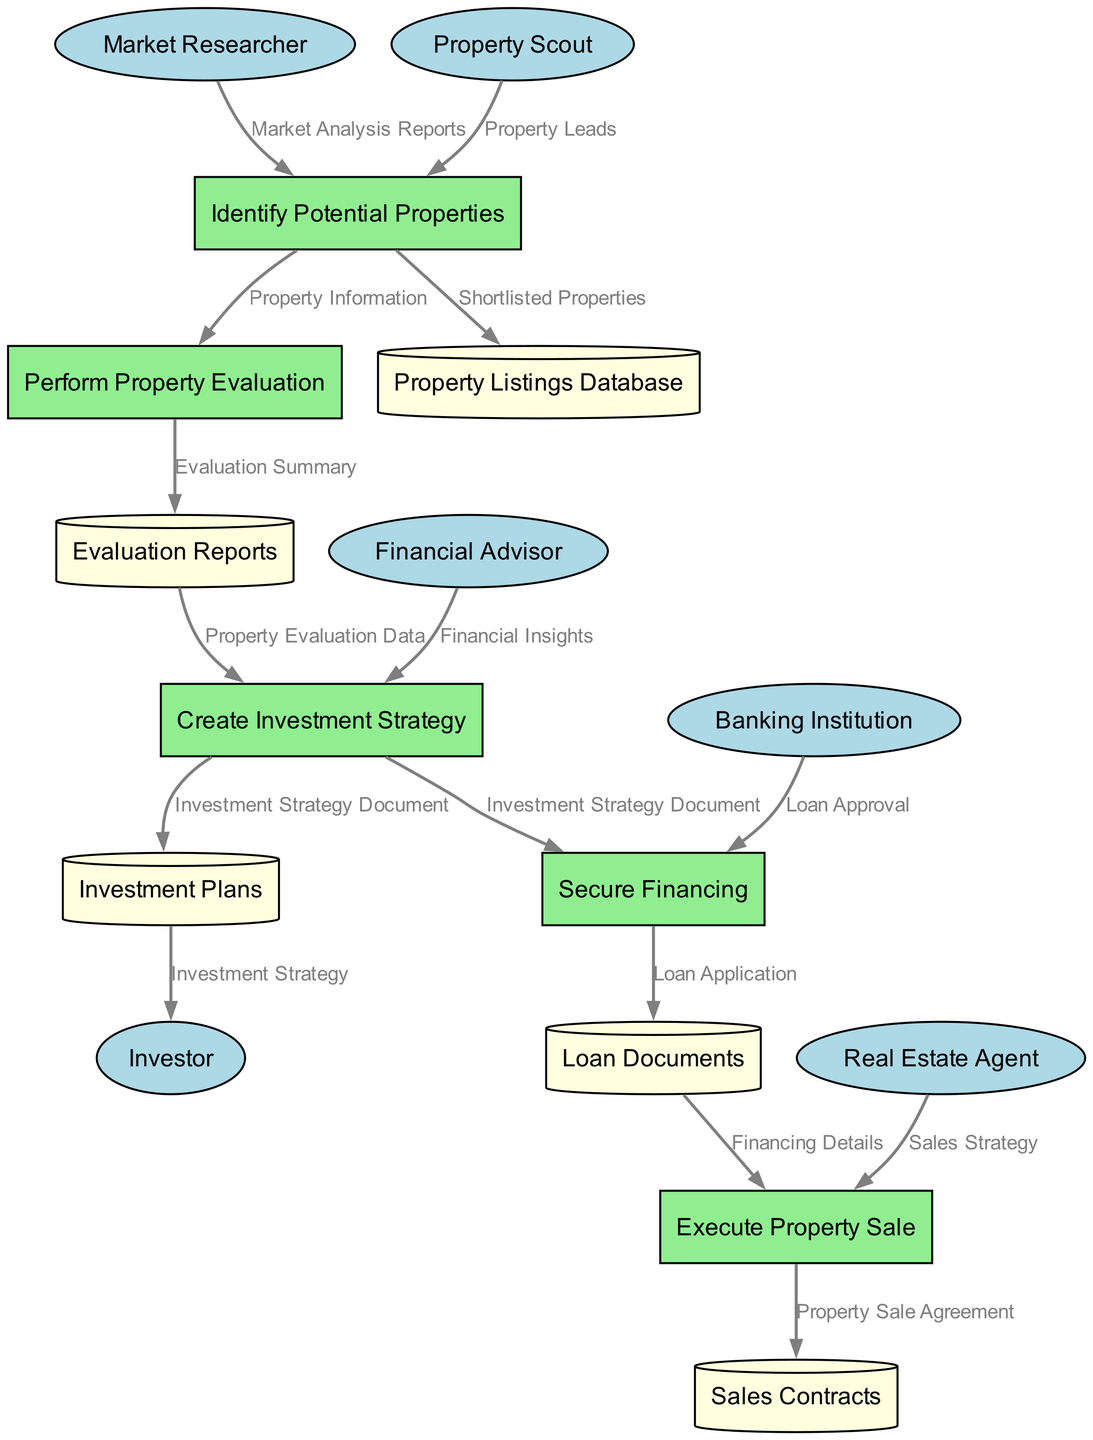What entities are involved in the process? The diagram lists six entities: Market Researcher, Property Scout, Financial Advisor, Real Estate Agent, Investor, and Banking Institution.
Answer: Six How many processes are defined in the diagram? The diagram includes five processes: Identify Potential Properties, Perform Property Evaluation, Create Investment Strategy, Secure Financing, and Execute Property Sale.
Answer: Five What is the data flow from the Property Scout? The Property Scout sends Property Leads to the Identify Potential Properties process.
Answer: Property Leads Which data store is related to Evaluation Reports? The Evaluation Reports data store is created by the Perform Property Evaluation process, which outputs the Evaluation Summary.
Answer: Evaluation Reports What data is provided to the Investor? The Investor receives the Investment Strategy from the Investment Plans data store.
Answer: Investment Strategy What is the first process in the diagram? The first process is Identify Potential Properties, which receives input from Market Researcher and Property Scout.
Answer: Identify Potential Properties How many edges flow from the Create Investment Strategy process? The Create Investment Strategy process has three outgoing edges: to Investment Plans, Secure Financing, and Evaluation Reports.
Answer: Three What document is required to secure financing? The Loan Application is necessary to secure financing, according to the data flow from Secure Financing to Loan Documents.
Answer: Loan Application What is the final output of the Execute Property Sale process? The final output from the Execute Property Sale process is the Property Sale Agreement, which is stored in the Sales Contracts data store.
Answer: Property Sale Agreement 